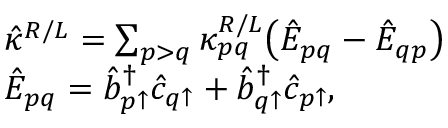Convert formula to latex. <formula><loc_0><loc_0><loc_500><loc_500>\begin{array} { r l } & { \hat { \kappa } ^ { R / L } = \sum _ { p > q } \kappa _ { p q } ^ { R / L } \left ( \hat { E } _ { p q } - \hat { E } _ { q p } \right ) } \\ & { \hat { E } _ { p q } = \hat { b } _ { p \uparrow } ^ { \dagger } \hat { c } _ { q \uparrow } + \hat { b } _ { q \uparrow } ^ { \dagger } \hat { c } _ { p \uparrow } , } \end{array}</formula> 